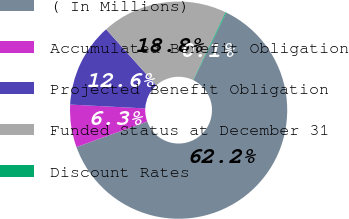Convert chart. <chart><loc_0><loc_0><loc_500><loc_500><pie_chart><fcel>( In Millions)<fcel>Accumulated Benefit Obligation<fcel>Projected Benefit Obligation<fcel>Funded Status at December 31<fcel>Discount Rates<nl><fcel>62.22%<fcel>6.34%<fcel>12.55%<fcel>18.76%<fcel>0.13%<nl></chart> 